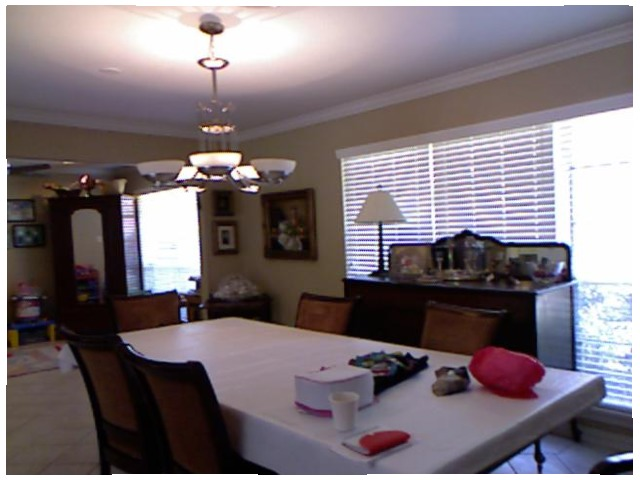<image>
Can you confirm if the cup is on the table? Yes. Looking at the image, I can see the cup is positioned on top of the table, with the table providing support. Is there a window behind the chair? Yes. From this viewpoint, the window is positioned behind the chair, with the chair partially or fully occluding the window. Is the chair behind the table? Yes. From this viewpoint, the chair is positioned behind the table, with the table partially or fully occluding the chair. Is the lamp above the calculator? No. The lamp is not positioned above the calculator. The vertical arrangement shows a different relationship. 